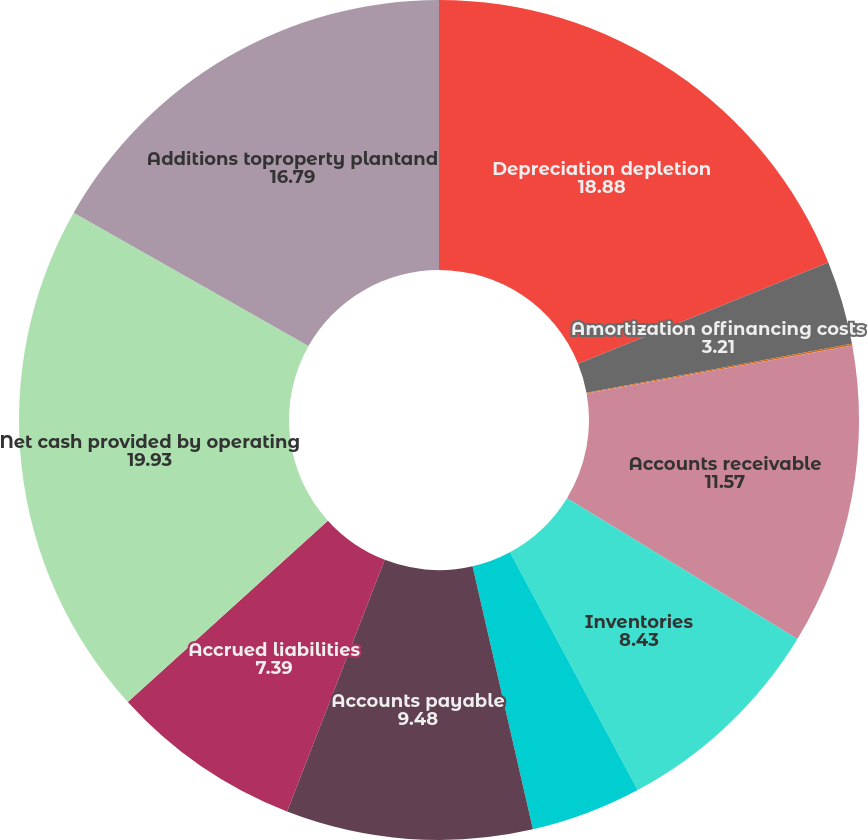Convert chart. <chart><loc_0><loc_0><loc_500><loc_500><pie_chart><fcel>Depreciation depletion<fcel>Amortization offinancing costs<fcel>Loss on disposal of property<fcel>Accounts receivable<fcel>Inventories<fcel>Prepaid expenses and other<fcel>Accounts payable<fcel>Accrued liabilities<fcel>Net cash provided by operating<fcel>Additions toproperty plantand<nl><fcel>18.88%<fcel>3.21%<fcel>0.07%<fcel>11.57%<fcel>8.43%<fcel>4.25%<fcel>9.48%<fcel>7.39%<fcel>19.93%<fcel>16.79%<nl></chart> 